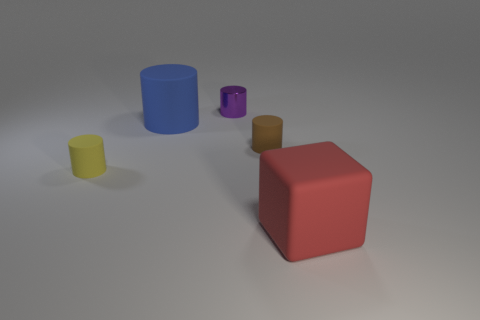Subtract all metal cylinders. How many cylinders are left? 3 Subtract all blocks. How many objects are left? 4 Subtract 1 blocks. How many blocks are left? 0 Subtract all yellow cylinders. Subtract all red spheres. How many cylinders are left? 3 Subtract all brown spheres. How many blue blocks are left? 0 Subtract all large blue objects. Subtract all small yellow objects. How many objects are left? 3 Add 2 tiny purple cylinders. How many tiny purple cylinders are left? 3 Add 2 small purple cylinders. How many small purple cylinders exist? 3 Add 2 small yellow things. How many objects exist? 7 Subtract all purple cylinders. How many cylinders are left? 3 